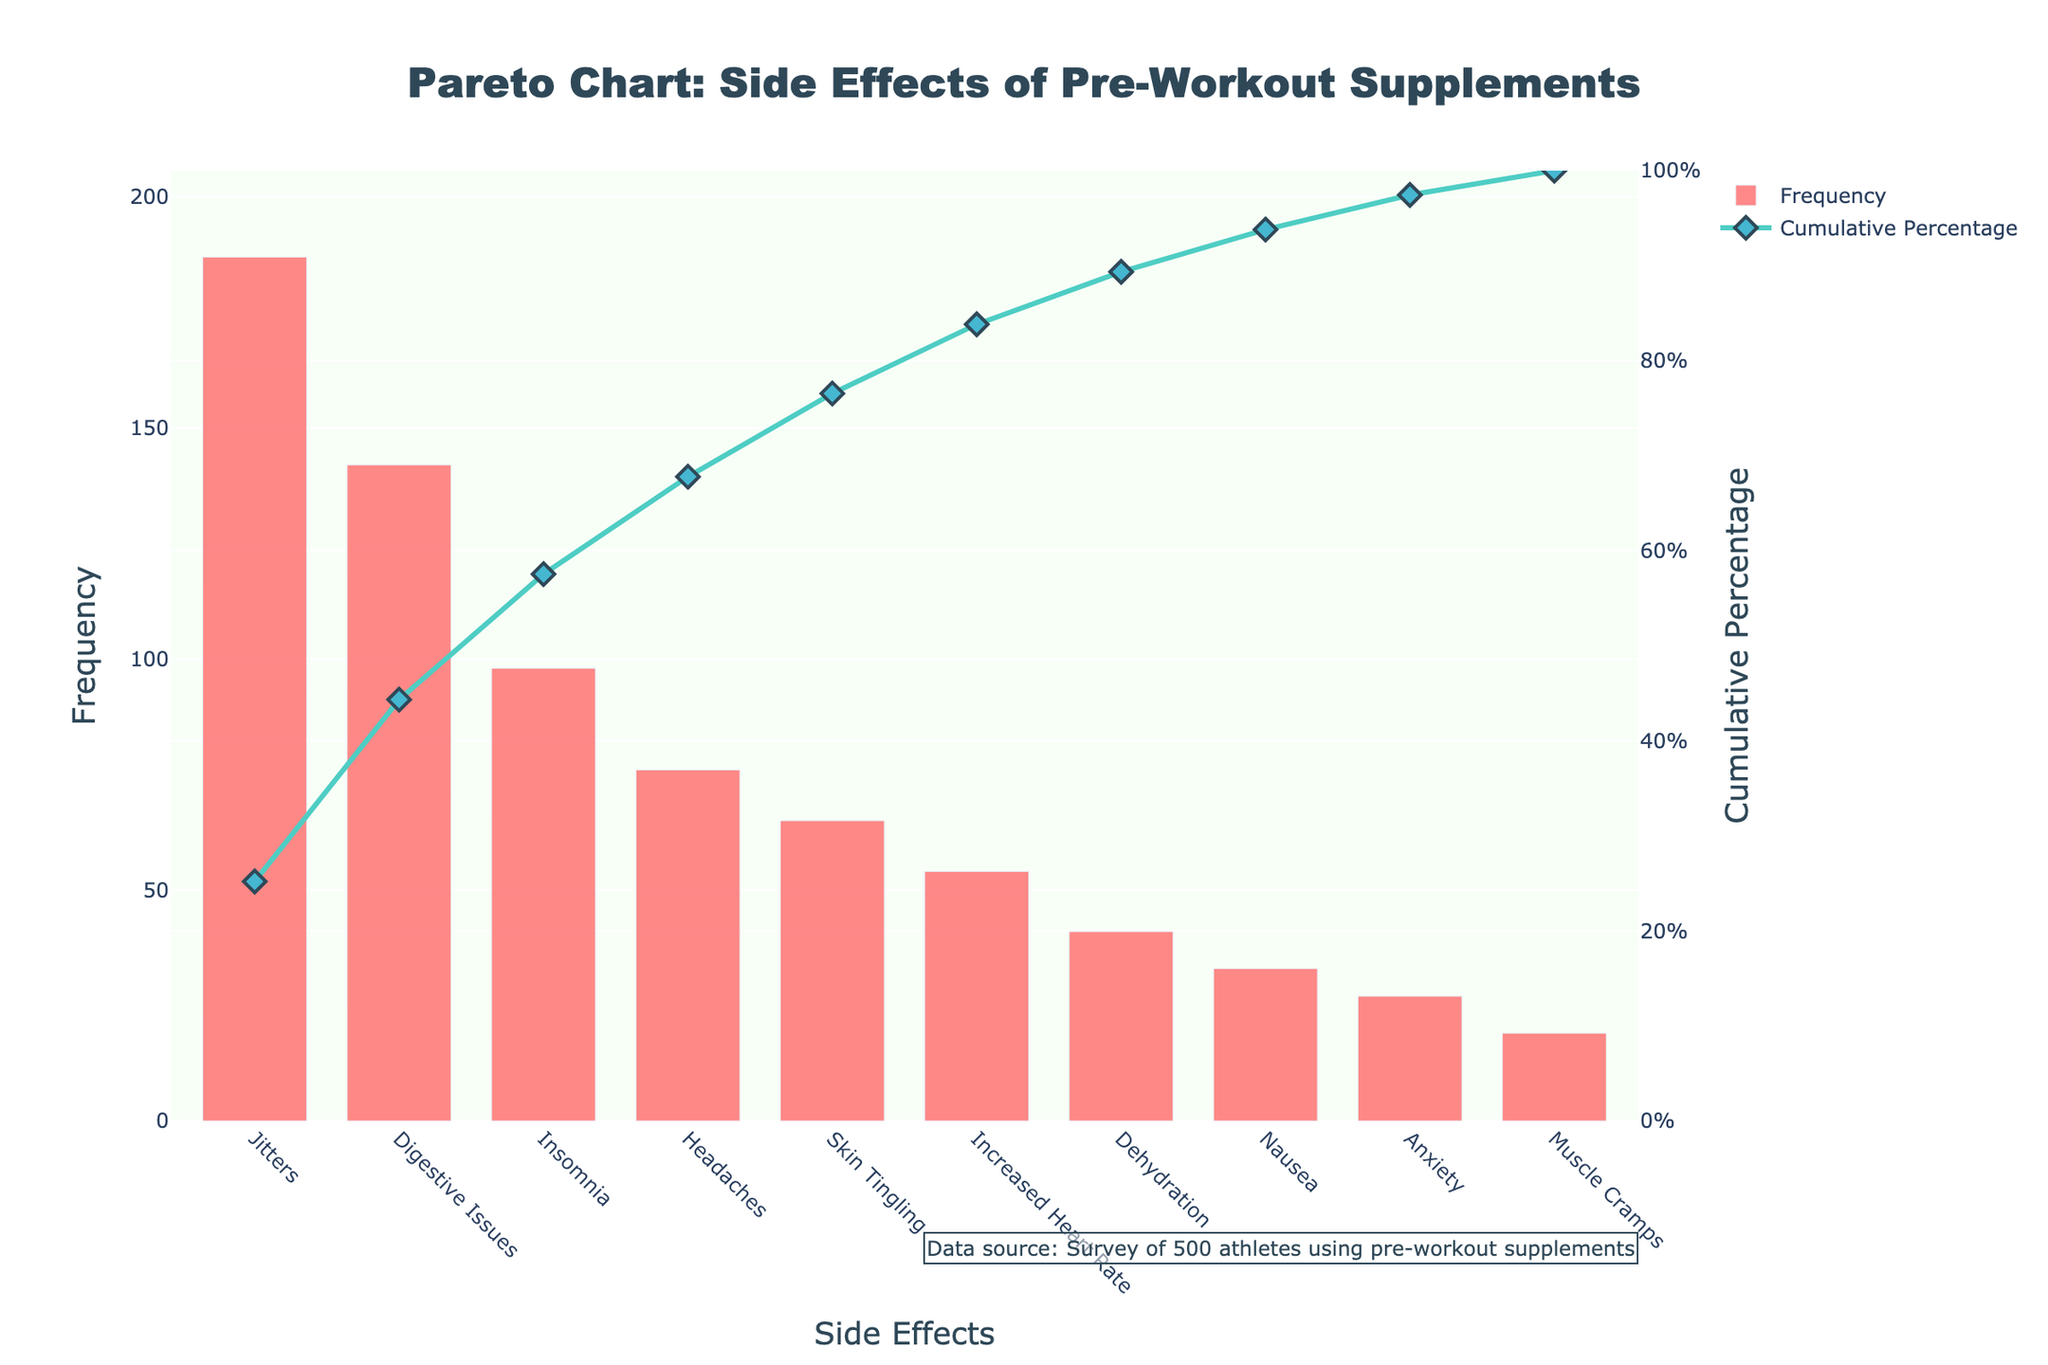What's the title of the figure? The title is displayed prominently at the top of the figure. The title is "Pareto Chart: Side Effects of Pre-Workout Supplements."
Answer: Pareto Chart: Side Effects of Pre-Workout Supplements What is the most frequently reported side effect? The highest bar on the left in the bar chart represents the most frequently reported side effect, labeled "Jitters."
Answer: Jitters How many side effects have a frequency above 100? Look at the bars in the chart and count those with frequencies above the 100 mark on the y-axis. There are two such side effects: "Jitters" and "Digestive Issues."
Answer: 2 What's the cumulative percentage for "Insomnia"? Locate the "Insomnia" label on the x-axis and follow upward to the corresponding point on the line chart, which shows the cumulative percentage.
Answer: Approximately 68% What is the frequency of the least reported side effect? The shortest bar on the right of the bar chart represents the least reported side effect, which is "Muscle Cramps." The frequency is shown at the top of the bar.
Answer: 19 How many side effects account for approximately 50% of the cumulative percentage? Identify the side effects on the x-axis and follow the cumulative percentage line until it reaches around the 50% mark. "Jitters," "Digestive Issues," and "Insomnia" collectively account for just over 50%.
Answer: 3 What side effect has a cumulative percentage closest to 90%? Depending on the cumulative percentage line, find the side effect that corresponds to the closest value to 90%. The closest cumulative percentage to 90% is for "Nausea."
Answer: Nausea Which side effect has a higher frequency, "Headaches" or "Skin Tingling"? Compare the heights of the bars labeled "Headaches" and "Skin Tingling." The bar for "Headaches" is taller.
Answer: Headaches What is the difference in frequency between "Increased Heart Rate" and "Dehydration"? Find the heights of the bars for "Increased Heart Rate" and "Dehydration," then subtract the frequency of "Dehydration" from that of "Increased Heart Rate" (54 - 41).
Answer: 13 How many side effects have frequencies less than 50? Locate the bars on the bar chart that have heights below the 50 mark on the y-axis. Count these bars: "Dehydration," "Nausea," "Anxiety," and "Muscle Cramps."
Answer: 4 